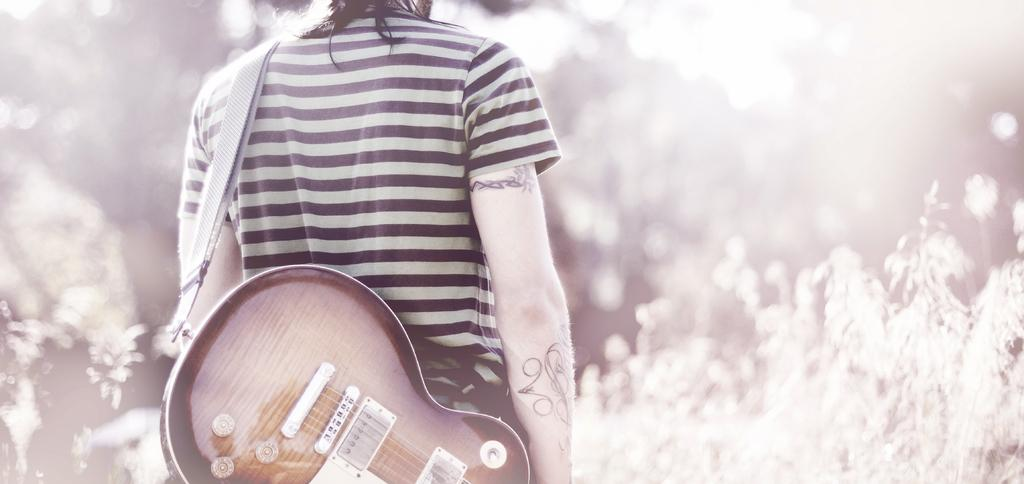What is the main subject of the image? The main subject of the image is a person. What is the person doing in the image? The person is standing in the image. What object is the person holding in the image? The person is holding a guitar in the image. Can you see any islands in the background of the image? There is no reference to an island or any background in the image; it only features a person standing and holding a guitar. What type of nose does the person have in the image? The image does not provide enough detail to determine the person's nose type. 